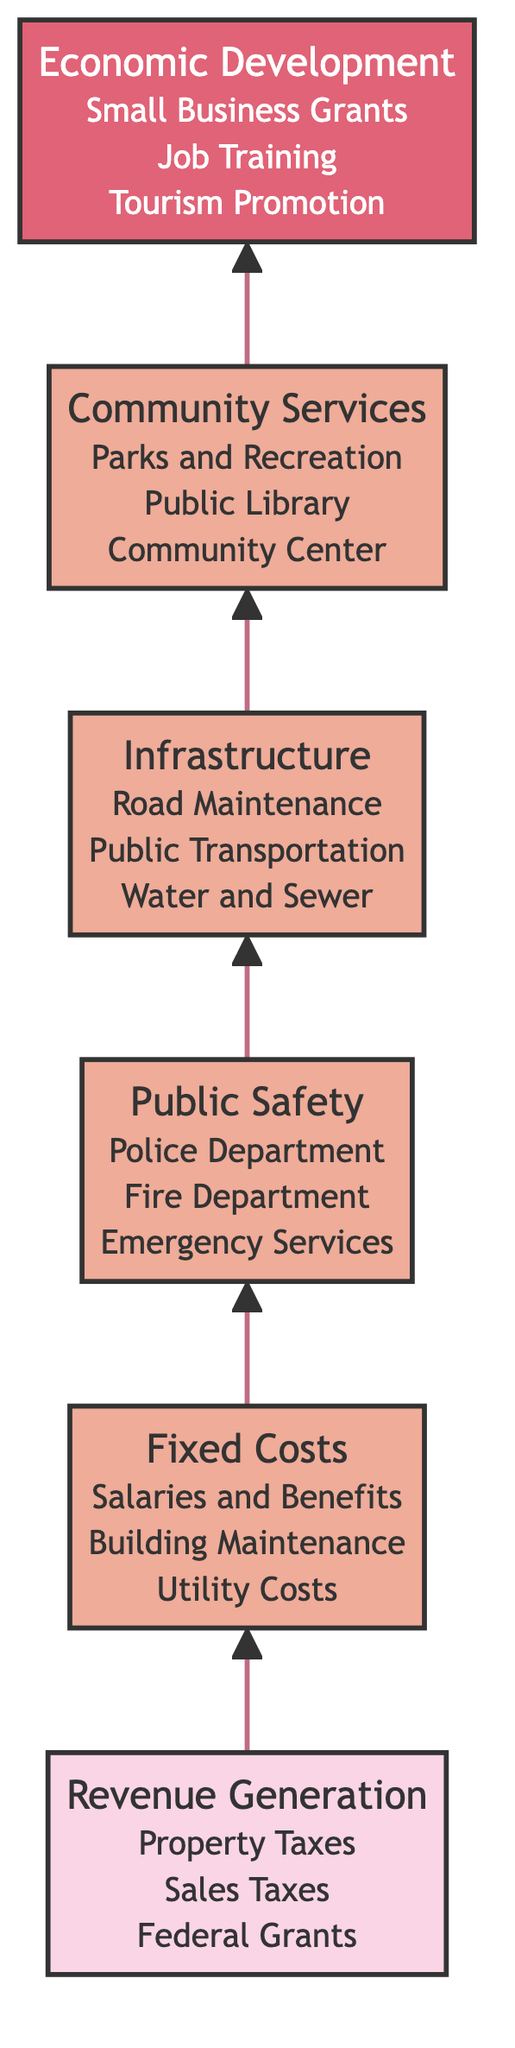What is the top element in the diagram? The diagram is structured in a Bottom to Top flow, where the top element represents the ultimate goal of budget allocation. By looking at the highest level, we see "Economic Development and Strategic Initiatives."
Answer: Economic Development and Strategic Initiatives How many levels are there in the flowchart? Each distinct category represents a level in the flowchart, starting from the base to the top. The levels are: Base, Level 1, Level 2, Level 3, Level 4, and Top, totaling six levels.
Answer: Six What connects Revenue Generation to Fixed Costs? The diagram showcases the flow of budget allocation with arrows indicating direct relationships. The arrow from "Revenue Generation" to "Fixed Costs" signifies that revenue generated supports the fixed costs of the town.
Answer: An arrow Which element is directly above Community Services? In the flowchart, the hierarchy is structured such that each level builds on the previous one. Therefore, the element directly above "Community Services" is "Infrastructure."
Answer: Infrastructure What are the details associated with Public Safety? The details relating to "Public Safety" are outlined under its element. They specifically include funding for the "Police Department," "Fire Department," and "Emergency Medical Services."
Answer: Police Department Funding, Fire Department Funding, Emergency Medical Services How does the flow of this diagram progress? The diagram effectively illustrates the flow from the bottom to the top, indicating how raw revenue at the base level transitions through fixed costs and essential services, ultimately culminating in economic initiatives at the top. Each layer feeds into the next successively.
Answer: From Revenue Generation to Economic Development Which element has the most detailed aspects in the diagram? By analyzing the nodes, "Economic Development and Strategic Initiatives" provide the most detailed aspects as it lists specific initiatives, which include "Small Business Grants," "Job Training Programs," and "Tourism Promotion."
Answer: Economic Development and Strategic Initiatives What is the relationship between Fixed Costs and Public Safety? The relationship between "Fixed Costs" and "Public Safety" shows that prior expenditures on fixed costs must be allocated before funds can be directed towards public safety initiatives. The upward arrow indicates a direct flow from fixed costs to public safety funding.
Answer: An upward arrow Which element encompasses funding for community resources? The element labeled "Community Services" clearly outlines funding for various community resources, such as "Parks and Recreation," "Public Library Funding," and "Community Center Operability."
Answer: Community Services 